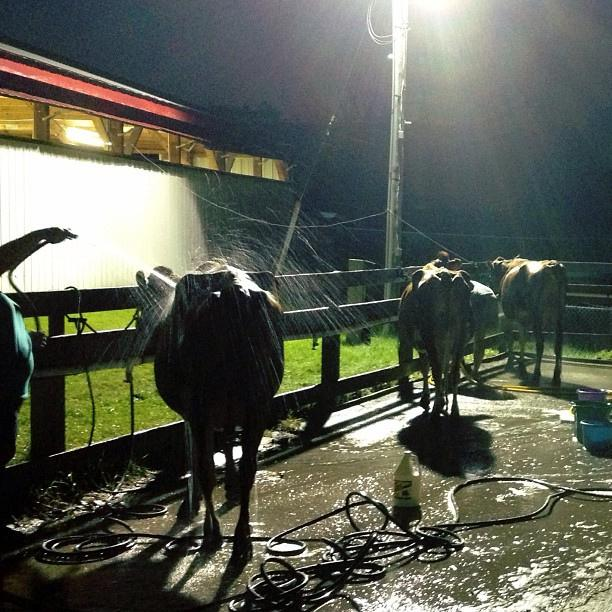What is happening in the photo? Please explain your reasoning. cow showering. The cow is showering. 